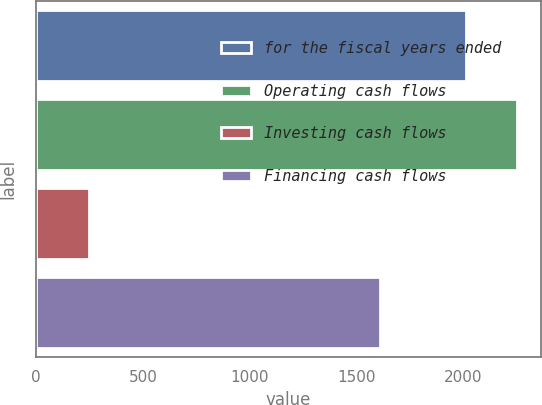Convert chart to OTSL. <chart><loc_0><loc_0><loc_500><loc_500><bar_chart><fcel>for the fiscal years ended<fcel>Operating cash flows<fcel>Investing cash flows<fcel>Financing cash flows<nl><fcel>2015<fcel>2252<fcel>248.9<fcel>1612.2<nl></chart> 